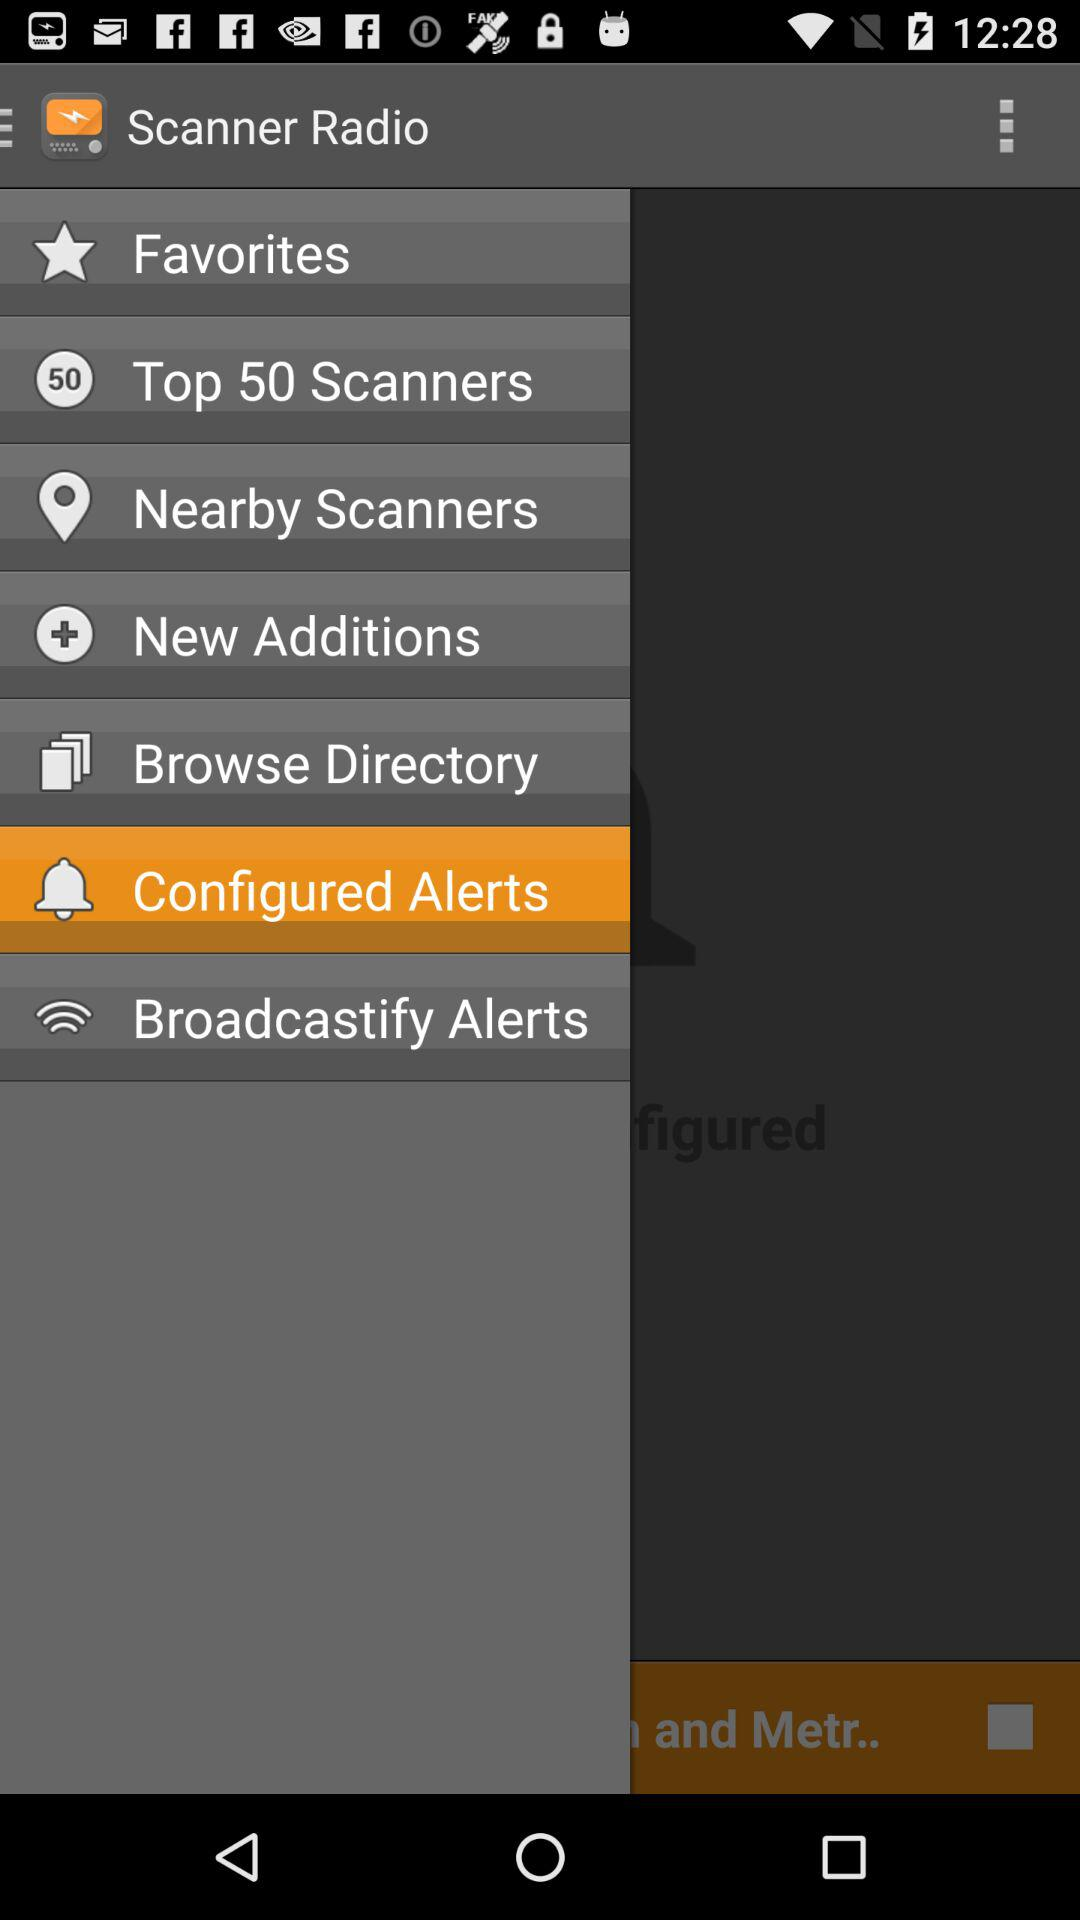What is the application name? The application name is "Scanner Radio". 